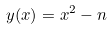Convert formula to latex. <formula><loc_0><loc_0><loc_500><loc_500>y ( x ) = x ^ { 2 } - n</formula> 